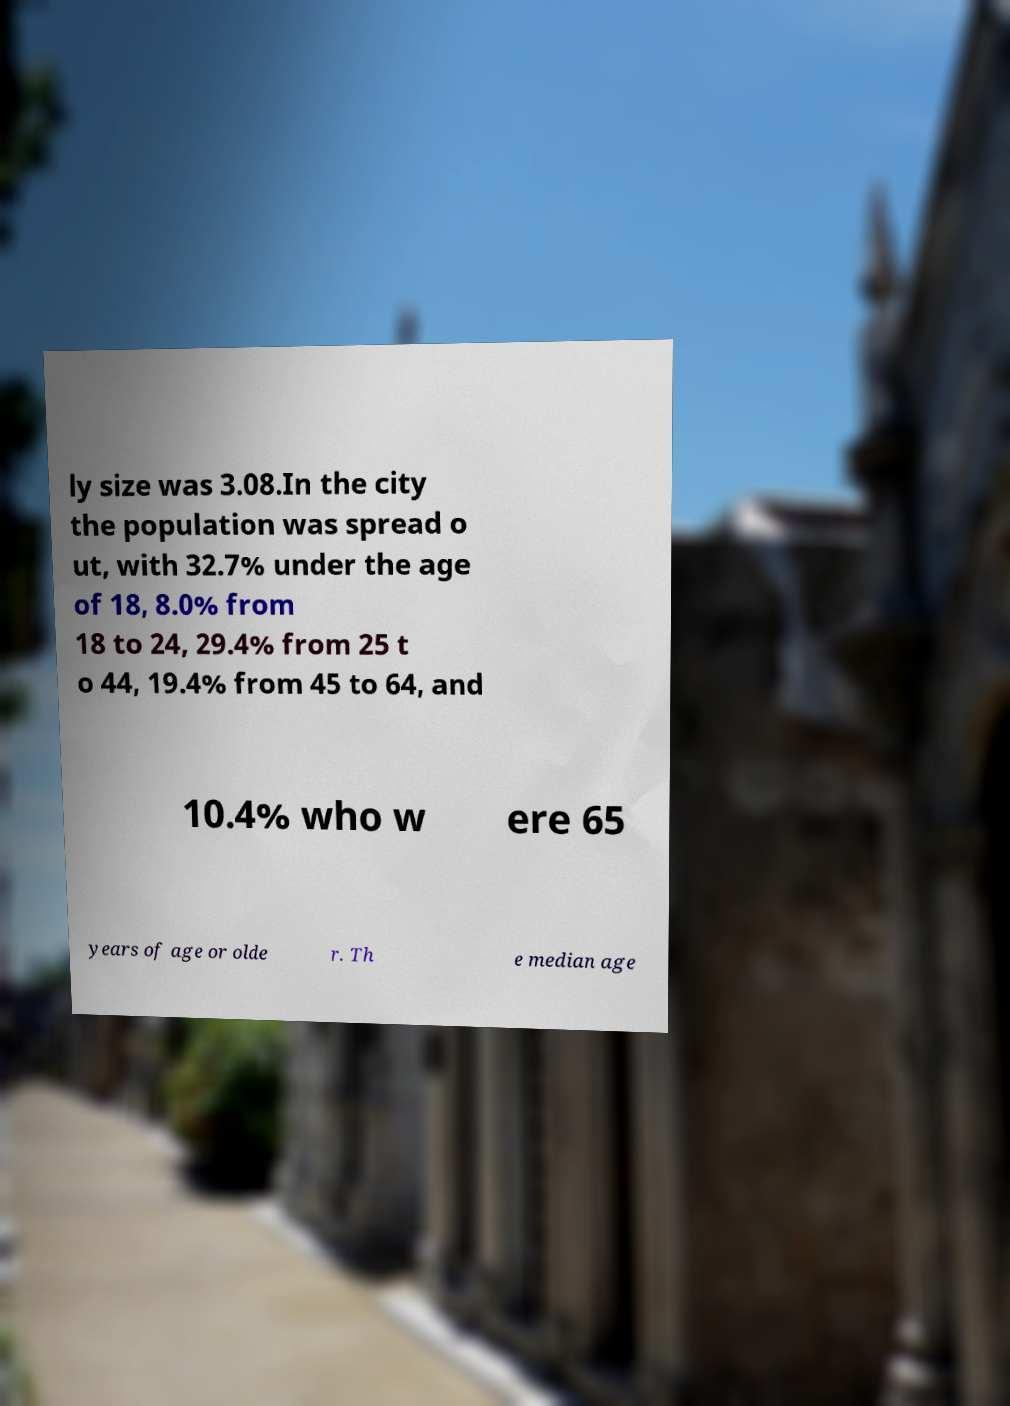Can you read and provide the text displayed in the image?This photo seems to have some interesting text. Can you extract and type it out for me? ly size was 3.08.In the city the population was spread o ut, with 32.7% under the age of 18, 8.0% from 18 to 24, 29.4% from 25 t o 44, 19.4% from 45 to 64, and 10.4% who w ere 65 years of age or olde r. Th e median age 